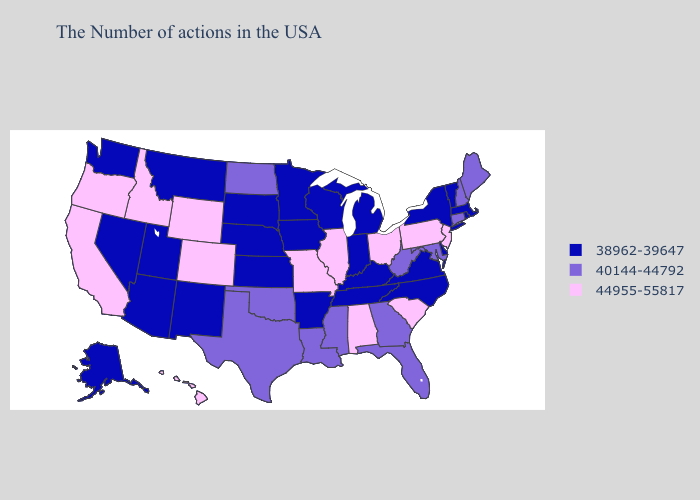What is the value of Vermont?
Keep it brief. 38962-39647. What is the lowest value in states that border Oregon?
Give a very brief answer. 38962-39647. Does Maine have the lowest value in the Northeast?
Quick response, please. No. Which states have the lowest value in the USA?
Short answer required. Massachusetts, Rhode Island, Vermont, New York, Delaware, Virginia, North Carolina, Michigan, Kentucky, Indiana, Tennessee, Wisconsin, Arkansas, Minnesota, Iowa, Kansas, Nebraska, South Dakota, New Mexico, Utah, Montana, Arizona, Nevada, Washington, Alaska. How many symbols are there in the legend?
Write a very short answer. 3. Does the first symbol in the legend represent the smallest category?
Keep it brief. Yes. Does Wisconsin have the same value as Minnesota?
Quick response, please. Yes. Which states have the lowest value in the USA?
Short answer required. Massachusetts, Rhode Island, Vermont, New York, Delaware, Virginia, North Carolina, Michigan, Kentucky, Indiana, Tennessee, Wisconsin, Arkansas, Minnesota, Iowa, Kansas, Nebraska, South Dakota, New Mexico, Utah, Montana, Arizona, Nevada, Washington, Alaska. What is the value of Kentucky?
Short answer required. 38962-39647. Name the states that have a value in the range 40144-44792?
Keep it brief. Maine, New Hampshire, Connecticut, Maryland, West Virginia, Florida, Georgia, Mississippi, Louisiana, Oklahoma, Texas, North Dakota. Among the states that border Utah , does Idaho have the highest value?
Be succinct. Yes. Which states have the highest value in the USA?
Answer briefly. New Jersey, Pennsylvania, South Carolina, Ohio, Alabama, Illinois, Missouri, Wyoming, Colorado, Idaho, California, Oregon, Hawaii. What is the value of Arizona?
Keep it brief. 38962-39647. Name the states that have a value in the range 38962-39647?
Answer briefly. Massachusetts, Rhode Island, Vermont, New York, Delaware, Virginia, North Carolina, Michigan, Kentucky, Indiana, Tennessee, Wisconsin, Arkansas, Minnesota, Iowa, Kansas, Nebraska, South Dakota, New Mexico, Utah, Montana, Arizona, Nevada, Washington, Alaska. What is the value of North Carolina?
Write a very short answer. 38962-39647. 